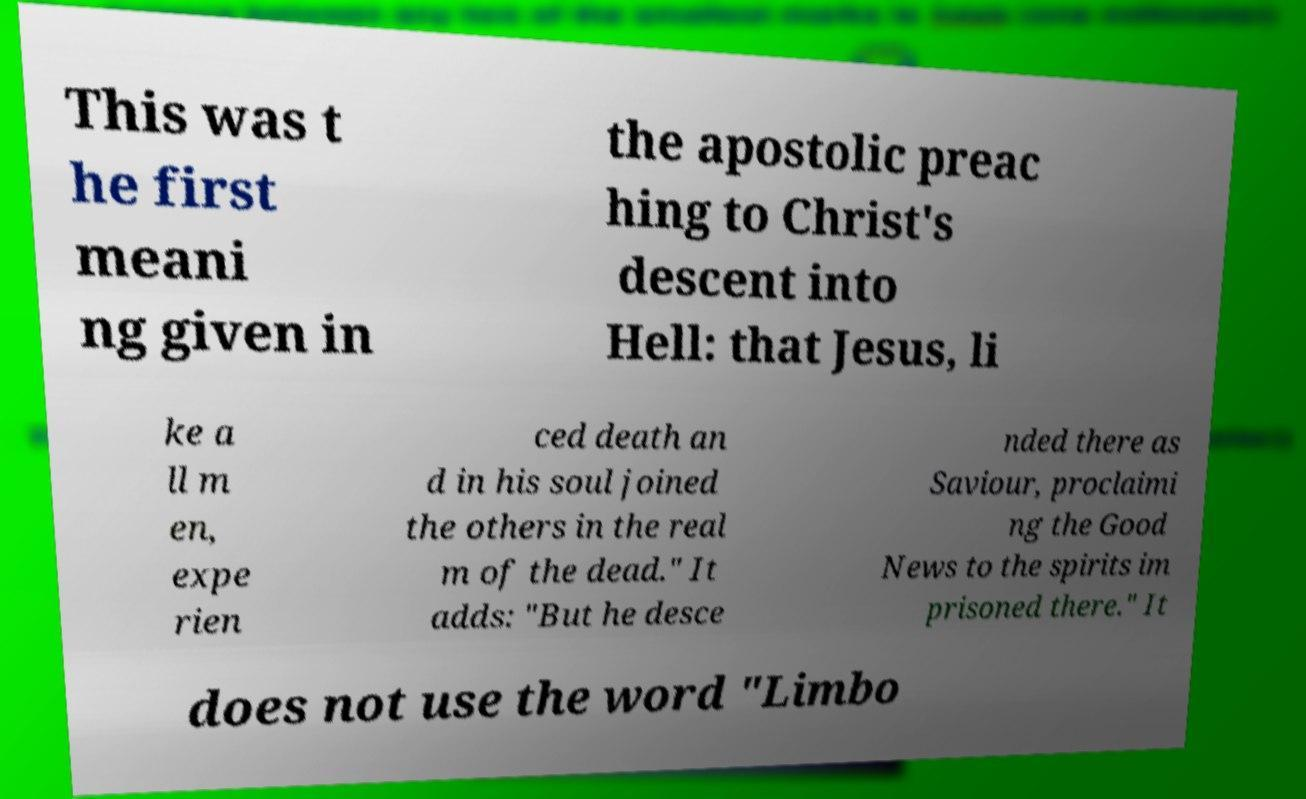Please read and relay the text visible in this image. What does it say? This was t he first meani ng given in the apostolic preac hing to Christ's descent into Hell: that Jesus, li ke a ll m en, expe rien ced death an d in his soul joined the others in the real m of the dead." It adds: "But he desce nded there as Saviour, proclaimi ng the Good News to the spirits im prisoned there." It does not use the word "Limbo 